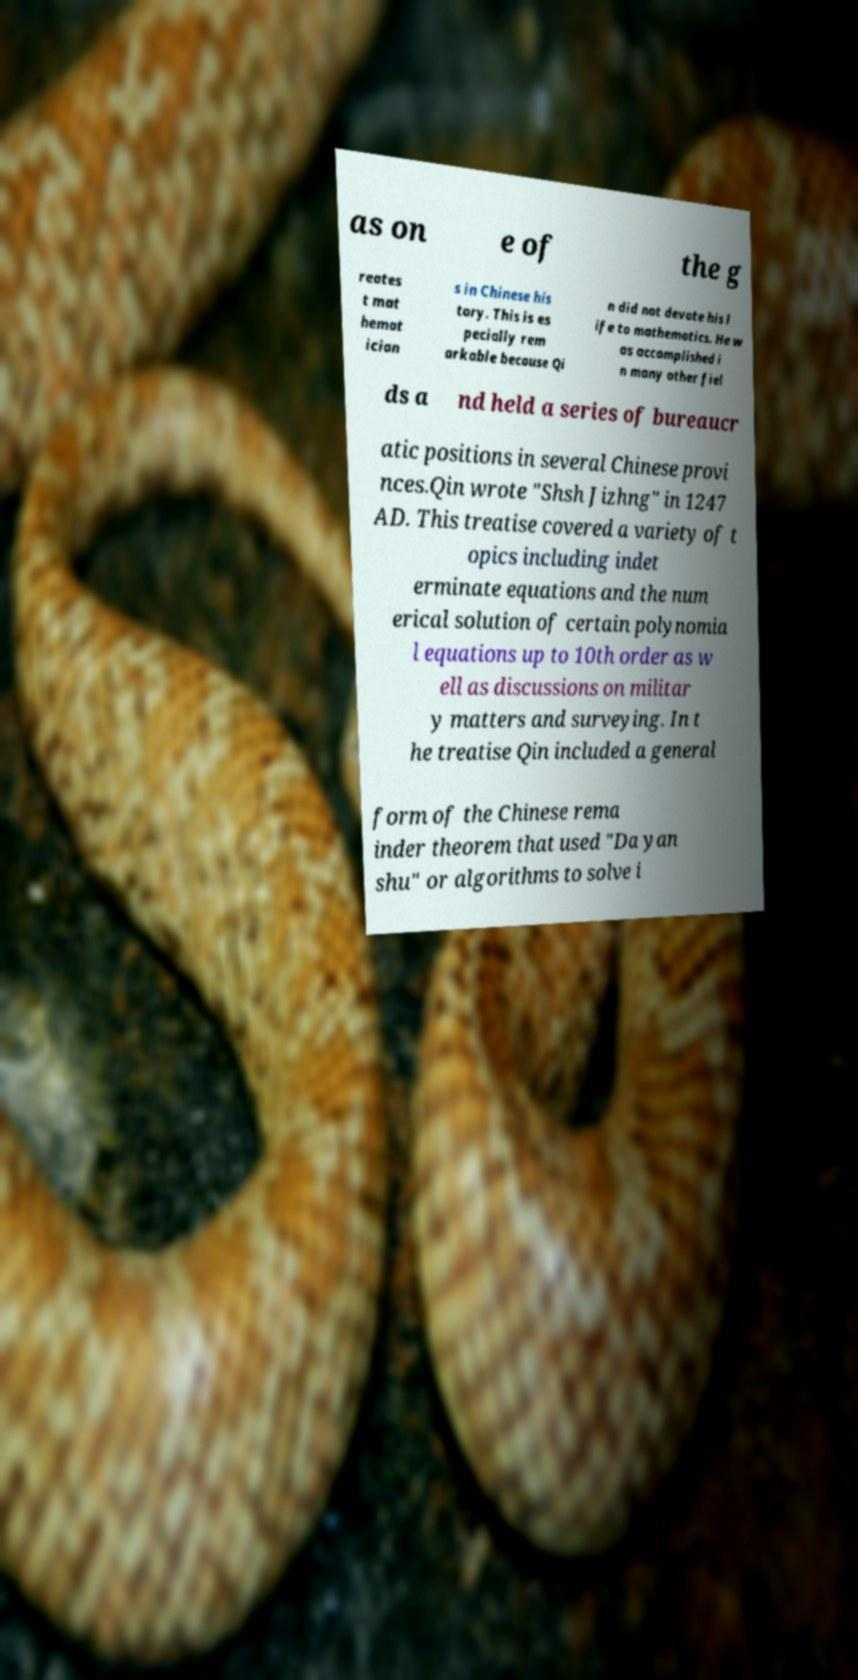Please identify and transcribe the text found in this image. as on e of the g reates t mat hemat ician s in Chinese his tory. This is es pecially rem arkable because Qi n did not devote his l ife to mathematics. He w as accomplished i n many other fiel ds a nd held a series of bureaucr atic positions in several Chinese provi nces.Qin wrote "Shsh Jizhng" in 1247 AD. This treatise covered a variety of t opics including indet erminate equations and the num erical solution of certain polynomia l equations up to 10th order as w ell as discussions on militar y matters and surveying. In t he treatise Qin included a general form of the Chinese rema inder theorem that used "Da yan shu" or algorithms to solve i 